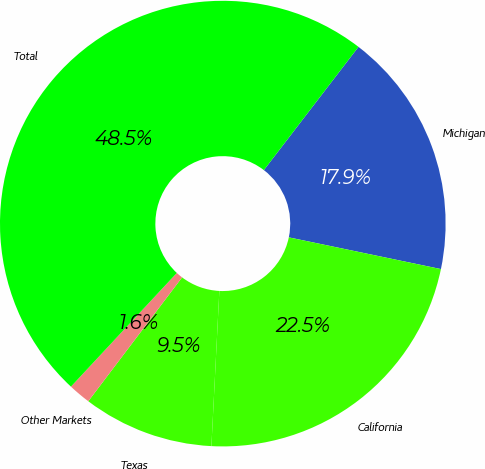<chart> <loc_0><loc_0><loc_500><loc_500><pie_chart><fcel>Michigan<fcel>California<fcel>Texas<fcel>Other Markets<fcel>Total<nl><fcel>17.85%<fcel>22.54%<fcel>9.5%<fcel>1.62%<fcel>48.48%<nl></chart> 